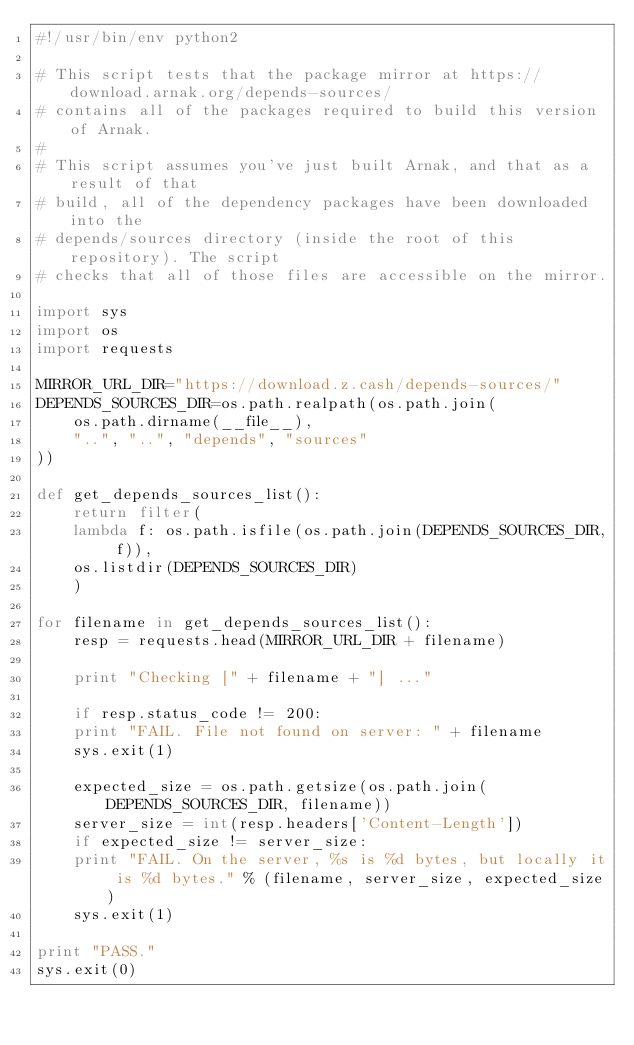Convert code to text. <code><loc_0><loc_0><loc_500><loc_500><_Python_>#!/usr/bin/env python2

# This script tests that the package mirror at https://download.arnak.org/depends-sources/
# contains all of the packages required to build this version of Arnak.
#
# This script assumes you've just built Arnak, and that as a result of that
# build, all of the dependency packages have been downloaded into the
# depends/sources directory (inside the root of this repository). The script
# checks that all of those files are accessible on the mirror.

import sys
import os
import requests

MIRROR_URL_DIR="https://download.z.cash/depends-sources/"
DEPENDS_SOURCES_DIR=os.path.realpath(os.path.join(
    os.path.dirname(__file__),
    "..", "..", "depends", "sources"
))

def get_depends_sources_list():
    return filter(
	lambda f: os.path.isfile(os.path.join(DEPENDS_SOURCES_DIR, f)),
	os.listdir(DEPENDS_SOURCES_DIR)
    )

for filename in get_depends_sources_list():
    resp = requests.head(MIRROR_URL_DIR + filename)

    print "Checking [" + filename + "] ..."

    if resp.status_code != 200:
	print "FAIL. File not found on server: " + filename
	sys.exit(1)

    expected_size = os.path.getsize(os.path.join(DEPENDS_SOURCES_DIR, filename))
    server_size = int(resp.headers['Content-Length'])
    if expected_size != server_size:
	print "FAIL. On the server, %s is %d bytes, but locally it is %d bytes." % (filename, server_size, expected_size)
	sys.exit(1)

print "PASS."
sys.exit(0)
</code> 